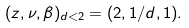Convert formula to latex. <formula><loc_0><loc_0><loc_500><loc_500>( z , \nu , \beta ) _ { d < 2 } = ( 2 , 1 / d , 1 ) .</formula> 